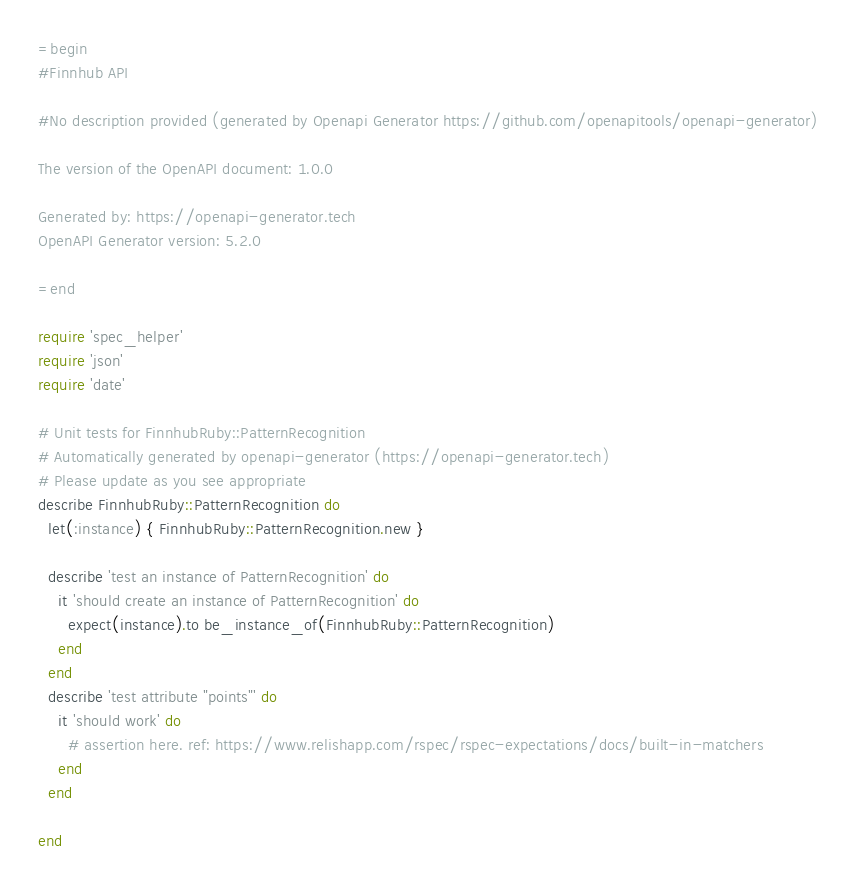Convert code to text. <code><loc_0><loc_0><loc_500><loc_500><_Ruby_>=begin
#Finnhub API

#No description provided (generated by Openapi Generator https://github.com/openapitools/openapi-generator)

The version of the OpenAPI document: 1.0.0

Generated by: https://openapi-generator.tech
OpenAPI Generator version: 5.2.0

=end

require 'spec_helper'
require 'json'
require 'date'

# Unit tests for FinnhubRuby::PatternRecognition
# Automatically generated by openapi-generator (https://openapi-generator.tech)
# Please update as you see appropriate
describe FinnhubRuby::PatternRecognition do
  let(:instance) { FinnhubRuby::PatternRecognition.new }

  describe 'test an instance of PatternRecognition' do
    it 'should create an instance of PatternRecognition' do
      expect(instance).to be_instance_of(FinnhubRuby::PatternRecognition)
    end
  end
  describe 'test attribute "points"' do
    it 'should work' do
      # assertion here. ref: https://www.relishapp.com/rspec/rspec-expectations/docs/built-in-matchers
    end
  end

end
</code> 